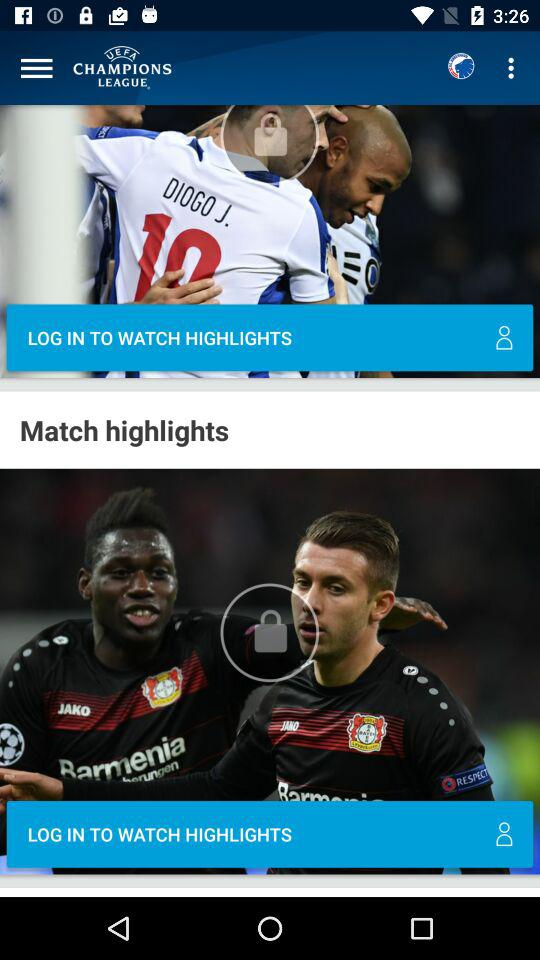What should we do to see the highlights? You should log in to see the highlights. 